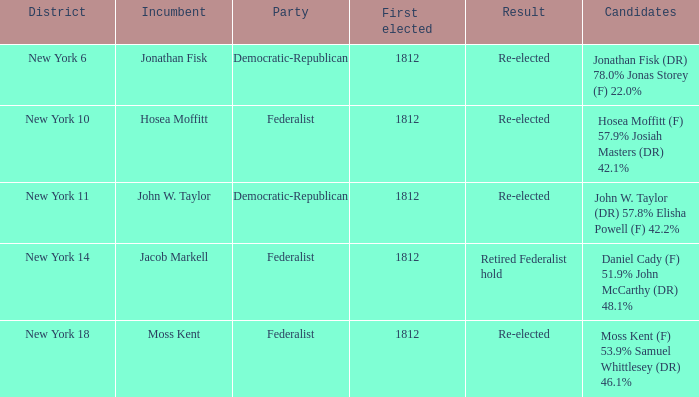Name the first elected for hosea moffitt (f) 57.9% josiah masters (dr) 42.1% 1812.0. 